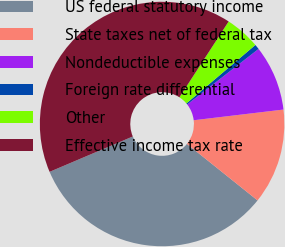<chart> <loc_0><loc_0><loc_500><loc_500><pie_chart><fcel>US federal statutory income<fcel>State taxes net of federal tax<fcel>Nondeductible expenses<fcel>Foreign rate differential<fcel>Other<fcel>Effective income tax rate<nl><fcel>32.86%<fcel>12.63%<fcel>8.64%<fcel>0.66%<fcel>4.65%<fcel>40.56%<nl></chart> 